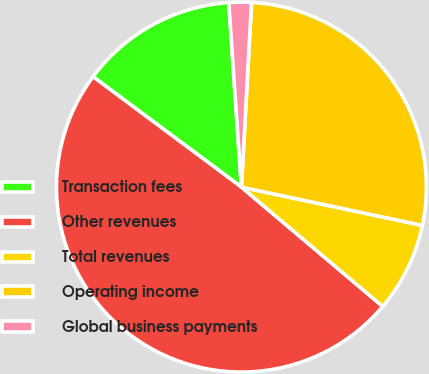<chart> <loc_0><loc_0><loc_500><loc_500><pie_chart><fcel>Transaction fees<fcel>Other revenues<fcel>Total revenues<fcel>Operating income<fcel>Global business payments<nl><fcel>13.73%<fcel>49.02%<fcel>7.84%<fcel>27.45%<fcel>1.96%<nl></chart> 